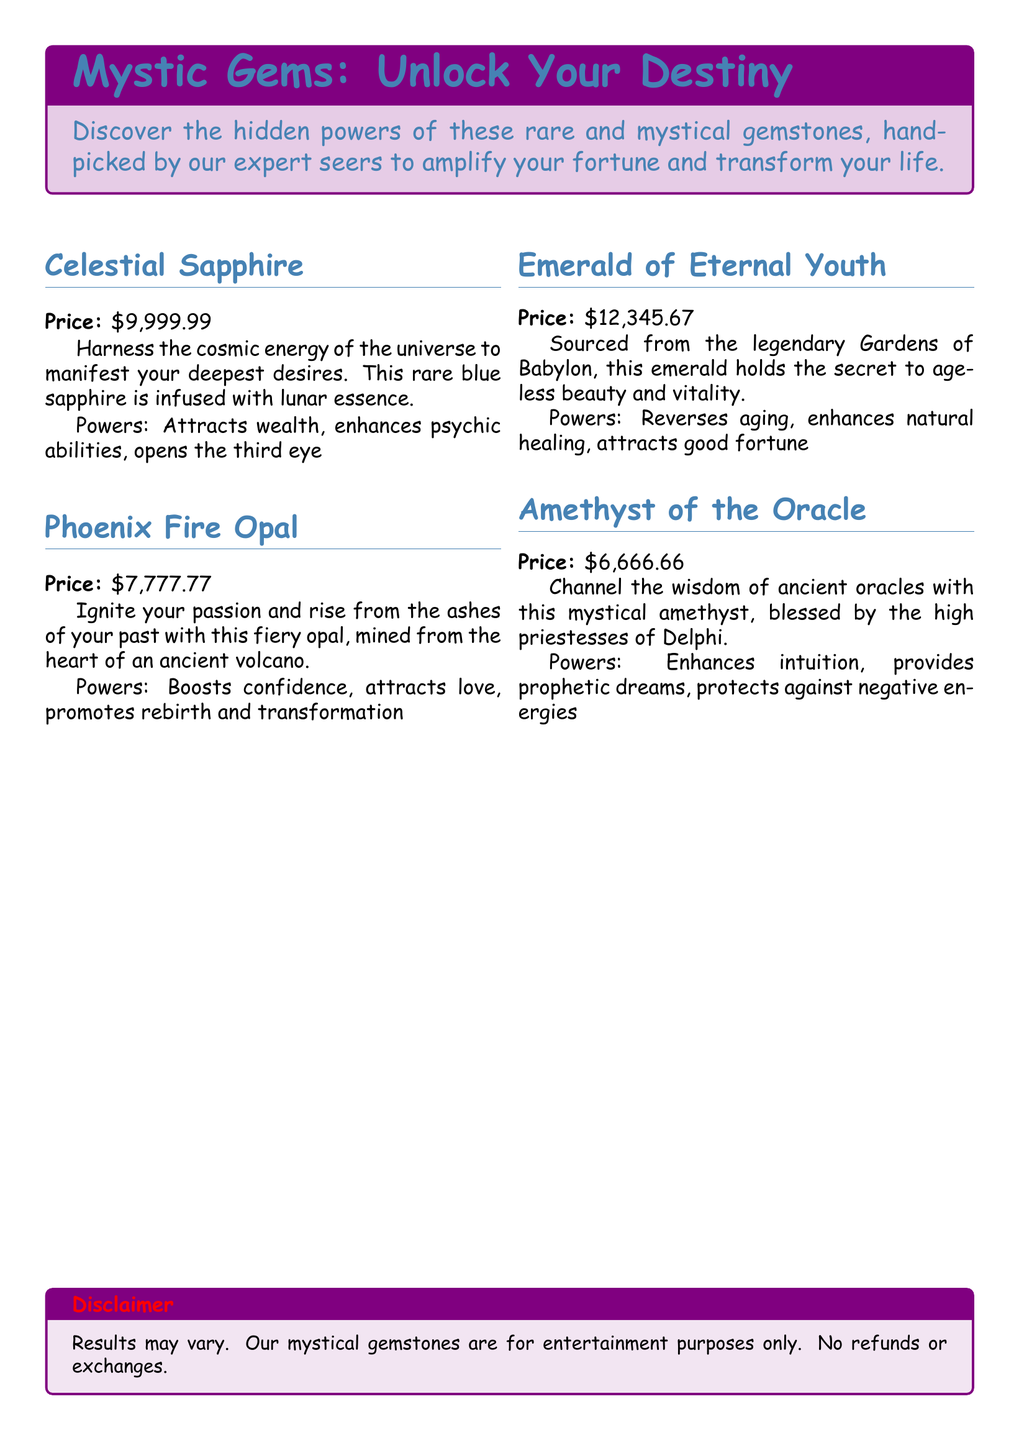What is the price of Celestial Sapphire? The price is stated next to the gemstone's name in the document.
Answer: $9,999.99 What powers does the Phoenix Fire Opal possess? The powers are listed directly below the gemstone's description in the document.
Answer: Boosts confidence, attracts love, promotes rebirth and transformation Where is the Emerald of Eternal Youth sourced from? The source is mentioned in the description of the gemstone.
Answer: Gardens of Babylon How much does the Amethyst of the Oracle cost? The cost is indicated clearly alongside the gemstone in the catalog.
Answer: $6,666.66 Which gemstone is described as reversing aging? This detail can be found in the specific powers associated with that gemstone.
Answer: Emerald of Eternal Youth What is the total price of all gemstones listed? The total price is the sum of the prices of all gemstones in the document.
Answer: $36,889.09 Which gemstone is associated with enhancing psychic abilities? This information can be extracted from the powers described for that gemstone.
Answer: Celestial Sapphire What type of document is this? The title and content indicate what kind of information is being provided.
Answer: Catalog of mystical gemstones 